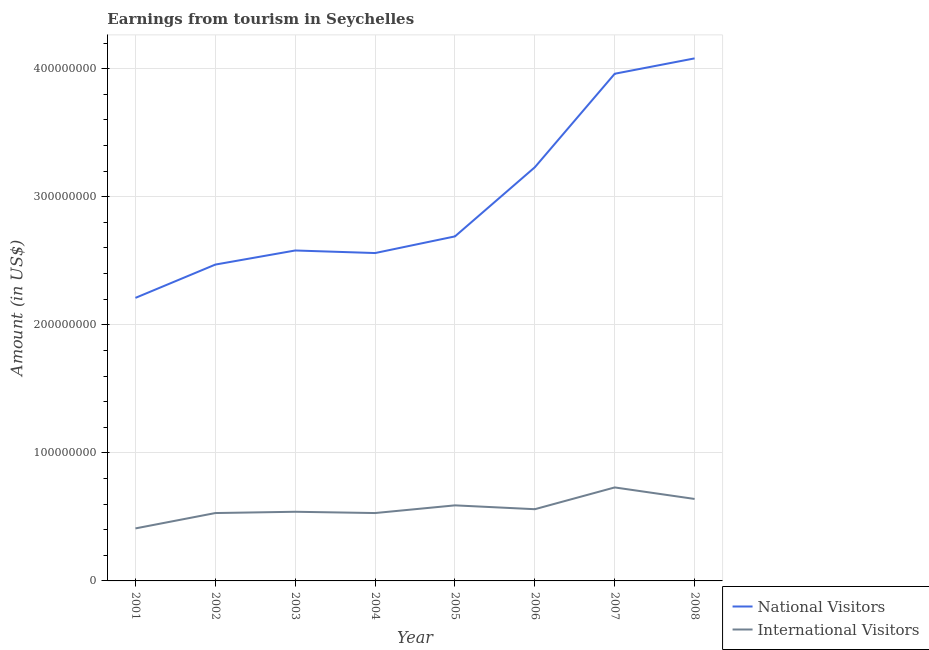Does the line corresponding to amount earned from national visitors intersect with the line corresponding to amount earned from international visitors?
Your answer should be compact. No. What is the amount earned from national visitors in 2007?
Your answer should be very brief. 3.96e+08. Across all years, what is the maximum amount earned from international visitors?
Provide a succinct answer. 7.30e+07. Across all years, what is the minimum amount earned from national visitors?
Your answer should be very brief. 2.21e+08. In which year was the amount earned from international visitors maximum?
Your answer should be compact. 2007. In which year was the amount earned from national visitors minimum?
Offer a very short reply. 2001. What is the total amount earned from international visitors in the graph?
Your response must be concise. 4.53e+08. What is the difference between the amount earned from international visitors in 2001 and that in 2003?
Your answer should be very brief. -1.30e+07. What is the difference between the amount earned from national visitors in 2005 and the amount earned from international visitors in 2001?
Your response must be concise. 2.28e+08. What is the average amount earned from international visitors per year?
Make the answer very short. 5.66e+07. In the year 2008, what is the difference between the amount earned from national visitors and amount earned from international visitors?
Provide a succinct answer. 3.44e+08. What is the ratio of the amount earned from international visitors in 2001 to that in 2003?
Your response must be concise. 0.76. Is the difference between the amount earned from national visitors in 2004 and 2006 greater than the difference between the amount earned from international visitors in 2004 and 2006?
Keep it short and to the point. No. What is the difference between the highest and the lowest amount earned from national visitors?
Your answer should be compact. 1.87e+08. Is the sum of the amount earned from national visitors in 2004 and 2007 greater than the maximum amount earned from international visitors across all years?
Make the answer very short. Yes. Does the amount earned from national visitors monotonically increase over the years?
Keep it short and to the point. No. Is the amount earned from international visitors strictly greater than the amount earned from national visitors over the years?
Provide a succinct answer. No. Is the amount earned from national visitors strictly less than the amount earned from international visitors over the years?
Provide a succinct answer. No. Does the graph contain any zero values?
Give a very brief answer. No. Does the graph contain grids?
Offer a very short reply. Yes. Where does the legend appear in the graph?
Your response must be concise. Bottom right. How are the legend labels stacked?
Offer a terse response. Vertical. What is the title of the graph?
Provide a short and direct response. Earnings from tourism in Seychelles. Does "Food and tobacco" appear as one of the legend labels in the graph?
Offer a terse response. No. What is the Amount (in US$) in National Visitors in 2001?
Offer a terse response. 2.21e+08. What is the Amount (in US$) of International Visitors in 2001?
Make the answer very short. 4.10e+07. What is the Amount (in US$) in National Visitors in 2002?
Make the answer very short. 2.47e+08. What is the Amount (in US$) of International Visitors in 2002?
Give a very brief answer. 5.30e+07. What is the Amount (in US$) in National Visitors in 2003?
Give a very brief answer. 2.58e+08. What is the Amount (in US$) in International Visitors in 2003?
Provide a succinct answer. 5.40e+07. What is the Amount (in US$) in National Visitors in 2004?
Ensure brevity in your answer.  2.56e+08. What is the Amount (in US$) of International Visitors in 2004?
Your answer should be compact. 5.30e+07. What is the Amount (in US$) in National Visitors in 2005?
Your response must be concise. 2.69e+08. What is the Amount (in US$) in International Visitors in 2005?
Provide a short and direct response. 5.90e+07. What is the Amount (in US$) of National Visitors in 2006?
Offer a terse response. 3.23e+08. What is the Amount (in US$) of International Visitors in 2006?
Make the answer very short. 5.60e+07. What is the Amount (in US$) of National Visitors in 2007?
Make the answer very short. 3.96e+08. What is the Amount (in US$) of International Visitors in 2007?
Keep it short and to the point. 7.30e+07. What is the Amount (in US$) in National Visitors in 2008?
Provide a short and direct response. 4.08e+08. What is the Amount (in US$) of International Visitors in 2008?
Give a very brief answer. 6.40e+07. Across all years, what is the maximum Amount (in US$) in National Visitors?
Your answer should be very brief. 4.08e+08. Across all years, what is the maximum Amount (in US$) in International Visitors?
Your answer should be very brief. 7.30e+07. Across all years, what is the minimum Amount (in US$) in National Visitors?
Your answer should be compact. 2.21e+08. Across all years, what is the minimum Amount (in US$) in International Visitors?
Offer a terse response. 4.10e+07. What is the total Amount (in US$) in National Visitors in the graph?
Your response must be concise. 2.38e+09. What is the total Amount (in US$) of International Visitors in the graph?
Your answer should be very brief. 4.53e+08. What is the difference between the Amount (in US$) of National Visitors in 2001 and that in 2002?
Make the answer very short. -2.60e+07. What is the difference between the Amount (in US$) in International Visitors in 2001 and that in 2002?
Give a very brief answer. -1.20e+07. What is the difference between the Amount (in US$) of National Visitors in 2001 and that in 2003?
Your answer should be compact. -3.70e+07. What is the difference between the Amount (in US$) of International Visitors in 2001 and that in 2003?
Your answer should be very brief. -1.30e+07. What is the difference between the Amount (in US$) of National Visitors in 2001 and that in 2004?
Offer a terse response. -3.50e+07. What is the difference between the Amount (in US$) in International Visitors in 2001 and that in 2004?
Make the answer very short. -1.20e+07. What is the difference between the Amount (in US$) in National Visitors in 2001 and that in 2005?
Keep it short and to the point. -4.80e+07. What is the difference between the Amount (in US$) of International Visitors in 2001 and that in 2005?
Make the answer very short. -1.80e+07. What is the difference between the Amount (in US$) of National Visitors in 2001 and that in 2006?
Give a very brief answer. -1.02e+08. What is the difference between the Amount (in US$) in International Visitors in 2001 and that in 2006?
Make the answer very short. -1.50e+07. What is the difference between the Amount (in US$) in National Visitors in 2001 and that in 2007?
Ensure brevity in your answer.  -1.75e+08. What is the difference between the Amount (in US$) in International Visitors in 2001 and that in 2007?
Give a very brief answer. -3.20e+07. What is the difference between the Amount (in US$) in National Visitors in 2001 and that in 2008?
Offer a terse response. -1.87e+08. What is the difference between the Amount (in US$) of International Visitors in 2001 and that in 2008?
Keep it short and to the point. -2.30e+07. What is the difference between the Amount (in US$) of National Visitors in 2002 and that in 2003?
Give a very brief answer. -1.10e+07. What is the difference between the Amount (in US$) in National Visitors in 2002 and that in 2004?
Provide a short and direct response. -9.00e+06. What is the difference between the Amount (in US$) of National Visitors in 2002 and that in 2005?
Ensure brevity in your answer.  -2.20e+07. What is the difference between the Amount (in US$) in International Visitors in 2002 and that in 2005?
Give a very brief answer. -6.00e+06. What is the difference between the Amount (in US$) of National Visitors in 2002 and that in 2006?
Make the answer very short. -7.60e+07. What is the difference between the Amount (in US$) of National Visitors in 2002 and that in 2007?
Give a very brief answer. -1.49e+08. What is the difference between the Amount (in US$) of International Visitors in 2002 and that in 2007?
Make the answer very short. -2.00e+07. What is the difference between the Amount (in US$) of National Visitors in 2002 and that in 2008?
Offer a terse response. -1.61e+08. What is the difference between the Amount (in US$) of International Visitors in 2002 and that in 2008?
Provide a short and direct response. -1.10e+07. What is the difference between the Amount (in US$) in National Visitors in 2003 and that in 2005?
Provide a succinct answer. -1.10e+07. What is the difference between the Amount (in US$) of International Visitors in 2003 and that in 2005?
Offer a very short reply. -5.00e+06. What is the difference between the Amount (in US$) of National Visitors in 2003 and that in 2006?
Your answer should be very brief. -6.50e+07. What is the difference between the Amount (in US$) in International Visitors in 2003 and that in 2006?
Offer a very short reply. -2.00e+06. What is the difference between the Amount (in US$) of National Visitors in 2003 and that in 2007?
Make the answer very short. -1.38e+08. What is the difference between the Amount (in US$) of International Visitors in 2003 and that in 2007?
Make the answer very short. -1.90e+07. What is the difference between the Amount (in US$) of National Visitors in 2003 and that in 2008?
Your answer should be compact. -1.50e+08. What is the difference between the Amount (in US$) of International Visitors in 2003 and that in 2008?
Keep it short and to the point. -1.00e+07. What is the difference between the Amount (in US$) in National Visitors in 2004 and that in 2005?
Ensure brevity in your answer.  -1.30e+07. What is the difference between the Amount (in US$) in International Visitors in 2004 and that in 2005?
Make the answer very short. -6.00e+06. What is the difference between the Amount (in US$) of National Visitors in 2004 and that in 2006?
Provide a short and direct response. -6.70e+07. What is the difference between the Amount (in US$) of International Visitors in 2004 and that in 2006?
Provide a succinct answer. -3.00e+06. What is the difference between the Amount (in US$) of National Visitors in 2004 and that in 2007?
Keep it short and to the point. -1.40e+08. What is the difference between the Amount (in US$) in International Visitors in 2004 and that in 2007?
Offer a terse response. -2.00e+07. What is the difference between the Amount (in US$) of National Visitors in 2004 and that in 2008?
Give a very brief answer. -1.52e+08. What is the difference between the Amount (in US$) in International Visitors in 2004 and that in 2008?
Your answer should be compact. -1.10e+07. What is the difference between the Amount (in US$) of National Visitors in 2005 and that in 2006?
Offer a very short reply. -5.40e+07. What is the difference between the Amount (in US$) in International Visitors in 2005 and that in 2006?
Your answer should be compact. 3.00e+06. What is the difference between the Amount (in US$) in National Visitors in 2005 and that in 2007?
Ensure brevity in your answer.  -1.27e+08. What is the difference between the Amount (in US$) of International Visitors in 2005 and that in 2007?
Ensure brevity in your answer.  -1.40e+07. What is the difference between the Amount (in US$) of National Visitors in 2005 and that in 2008?
Offer a terse response. -1.39e+08. What is the difference between the Amount (in US$) in International Visitors in 2005 and that in 2008?
Make the answer very short. -5.00e+06. What is the difference between the Amount (in US$) of National Visitors in 2006 and that in 2007?
Your answer should be very brief. -7.30e+07. What is the difference between the Amount (in US$) of International Visitors in 2006 and that in 2007?
Your answer should be very brief. -1.70e+07. What is the difference between the Amount (in US$) in National Visitors in 2006 and that in 2008?
Keep it short and to the point. -8.50e+07. What is the difference between the Amount (in US$) of International Visitors in 2006 and that in 2008?
Ensure brevity in your answer.  -8.00e+06. What is the difference between the Amount (in US$) in National Visitors in 2007 and that in 2008?
Offer a terse response. -1.20e+07. What is the difference between the Amount (in US$) of International Visitors in 2007 and that in 2008?
Your answer should be compact. 9.00e+06. What is the difference between the Amount (in US$) in National Visitors in 2001 and the Amount (in US$) in International Visitors in 2002?
Offer a terse response. 1.68e+08. What is the difference between the Amount (in US$) of National Visitors in 2001 and the Amount (in US$) of International Visitors in 2003?
Give a very brief answer. 1.67e+08. What is the difference between the Amount (in US$) of National Visitors in 2001 and the Amount (in US$) of International Visitors in 2004?
Keep it short and to the point. 1.68e+08. What is the difference between the Amount (in US$) in National Visitors in 2001 and the Amount (in US$) in International Visitors in 2005?
Your response must be concise. 1.62e+08. What is the difference between the Amount (in US$) of National Visitors in 2001 and the Amount (in US$) of International Visitors in 2006?
Give a very brief answer. 1.65e+08. What is the difference between the Amount (in US$) in National Visitors in 2001 and the Amount (in US$) in International Visitors in 2007?
Make the answer very short. 1.48e+08. What is the difference between the Amount (in US$) in National Visitors in 2001 and the Amount (in US$) in International Visitors in 2008?
Your answer should be compact. 1.57e+08. What is the difference between the Amount (in US$) of National Visitors in 2002 and the Amount (in US$) of International Visitors in 2003?
Make the answer very short. 1.93e+08. What is the difference between the Amount (in US$) of National Visitors in 2002 and the Amount (in US$) of International Visitors in 2004?
Offer a terse response. 1.94e+08. What is the difference between the Amount (in US$) in National Visitors in 2002 and the Amount (in US$) in International Visitors in 2005?
Ensure brevity in your answer.  1.88e+08. What is the difference between the Amount (in US$) of National Visitors in 2002 and the Amount (in US$) of International Visitors in 2006?
Make the answer very short. 1.91e+08. What is the difference between the Amount (in US$) of National Visitors in 2002 and the Amount (in US$) of International Visitors in 2007?
Make the answer very short. 1.74e+08. What is the difference between the Amount (in US$) in National Visitors in 2002 and the Amount (in US$) in International Visitors in 2008?
Provide a short and direct response. 1.83e+08. What is the difference between the Amount (in US$) of National Visitors in 2003 and the Amount (in US$) of International Visitors in 2004?
Provide a succinct answer. 2.05e+08. What is the difference between the Amount (in US$) of National Visitors in 2003 and the Amount (in US$) of International Visitors in 2005?
Your response must be concise. 1.99e+08. What is the difference between the Amount (in US$) in National Visitors in 2003 and the Amount (in US$) in International Visitors in 2006?
Offer a terse response. 2.02e+08. What is the difference between the Amount (in US$) in National Visitors in 2003 and the Amount (in US$) in International Visitors in 2007?
Your answer should be compact. 1.85e+08. What is the difference between the Amount (in US$) of National Visitors in 2003 and the Amount (in US$) of International Visitors in 2008?
Keep it short and to the point. 1.94e+08. What is the difference between the Amount (in US$) in National Visitors in 2004 and the Amount (in US$) in International Visitors in 2005?
Your answer should be compact. 1.97e+08. What is the difference between the Amount (in US$) in National Visitors in 2004 and the Amount (in US$) in International Visitors in 2006?
Give a very brief answer. 2.00e+08. What is the difference between the Amount (in US$) of National Visitors in 2004 and the Amount (in US$) of International Visitors in 2007?
Provide a short and direct response. 1.83e+08. What is the difference between the Amount (in US$) in National Visitors in 2004 and the Amount (in US$) in International Visitors in 2008?
Offer a very short reply. 1.92e+08. What is the difference between the Amount (in US$) in National Visitors in 2005 and the Amount (in US$) in International Visitors in 2006?
Your response must be concise. 2.13e+08. What is the difference between the Amount (in US$) of National Visitors in 2005 and the Amount (in US$) of International Visitors in 2007?
Provide a short and direct response. 1.96e+08. What is the difference between the Amount (in US$) of National Visitors in 2005 and the Amount (in US$) of International Visitors in 2008?
Provide a succinct answer. 2.05e+08. What is the difference between the Amount (in US$) of National Visitors in 2006 and the Amount (in US$) of International Visitors in 2007?
Make the answer very short. 2.50e+08. What is the difference between the Amount (in US$) in National Visitors in 2006 and the Amount (in US$) in International Visitors in 2008?
Offer a very short reply. 2.59e+08. What is the difference between the Amount (in US$) of National Visitors in 2007 and the Amount (in US$) of International Visitors in 2008?
Make the answer very short. 3.32e+08. What is the average Amount (in US$) of National Visitors per year?
Give a very brief answer. 2.97e+08. What is the average Amount (in US$) in International Visitors per year?
Offer a terse response. 5.66e+07. In the year 2001, what is the difference between the Amount (in US$) of National Visitors and Amount (in US$) of International Visitors?
Provide a succinct answer. 1.80e+08. In the year 2002, what is the difference between the Amount (in US$) of National Visitors and Amount (in US$) of International Visitors?
Give a very brief answer. 1.94e+08. In the year 2003, what is the difference between the Amount (in US$) of National Visitors and Amount (in US$) of International Visitors?
Ensure brevity in your answer.  2.04e+08. In the year 2004, what is the difference between the Amount (in US$) in National Visitors and Amount (in US$) in International Visitors?
Give a very brief answer. 2.03e+08. In the year 2005, what is the difference between the Amount (in US$) in National Visitors and Amount (in US$) in International Visitors?
Ensure brevity in your answer.  2.10e+08. In the year 2006, what is the difference between the Amount (in US$) in National Visitors and Amount (in US$) in International Visitors?
Your answer should be compact. 2.67e+08. In the year 2007, what is the difference between the Amount (in US$) in National Visitors and Amount (in US$) in International Visitors?
Ensure brevity in your answer.  3.23e+08. In the year 2008, what is the difference between the Amount (in US$) in National Visitors and Amount (in US$) in International Visitors?
Offer a very short reply. 3.44e+08. What is the ratio of the Amount (in US$) in National Visitors in 2001 to that in 2002?
Provide a succinct answer. 0.89. What is the ratio of the Amount (in US$) of International Visitors in 2001 to that in 2002?
Provide a succinct answer. 0.77. What is the ratio of the Amount (in US$) of National Visitors in 2001 to that in 2003?
Offer a terse response. 0.86. What is the ratio of the Amount (in US$) of International Visitors in 2001 to that in 2003?
Offer a terse response. 0.76. What is the ratio of the Amount (in US$) in National Visitors in 2001 to that in 2004?
Keep it short and to the point. 0.86. What is the ratio of the Amount (in US$) of International Visitors in 2001 to that in 2004?
Offer a very short reply. 0.77. What is the ratio of the Amount (in US$) of National Visitors in 2001 to that in 2005?
Ensure brevity in your answer.  0.82. What is the ratio of the Amount (in US$) of International Visitors in 2001 to that in 2005?
Provide a short and direct response. 0.69. What is the ratio of the Amount (in US$) in National Visitors in 2001 to that in 2006?
Your answer should be compact. 0.68. What is the ratio of the Amount (in US$) in International Visitors in 2001 to that in 2006?
Your answer should be compact. 0.73. What is the ratio of the Amount (in US$) of National Visitors in 2001 to that in 2007?
Keep it short and to the point. 0.56. What is the ratio of the Amount (in US$) of International Visitors in 2001 to that in 2007?
Offer a terse response. 0.56. What is the ratio of the Amount (in US$) of National Visitors in 2001 to that in 2008?
Your answer should be compact. 0.54. What is the ratio of the Amount (in US$) in International Visitors in 2001 to that in 2008?
Provide a short and direct response. 0.64. What is the ratio of the Amount (in US$) of National Visitors in 2002 to that in 2003?
Provide a short and direct response. 0.96. What is the ratio of the Amount (in US$) in International Visitors in 2002 to that in 2003?
Ensure brevity in your answer.  0.98. What is the ratio of the Amount (in US$) in National Visitors in 2002 to that in 2004?
Keep it short and to the point. 0.96. What is the ratio of the Amount (in US$) of National Visitors in 2002 to that in 2005?
Your response must be concise. 0.92. What is the ratio of the Amount (in US$) in International Visitors in 2002 to that in 2005?
Make the answer very short. 0.9. What is the ratio of the Amount (in US$) of National Visitors in 2002 to that in 2006?
Make the answer very short. 0.76. What is the ratio of the Amount (in US$) of International Visitors in 2002 to that in 2006?
Keep it short and to the point. 0.95. What is the ratio of the Amount (in US$) of National Visitors in 2002 to that in 2007?
Your answer should be compact. 0.62. What is the ratio of the Amount (in US$) in International Visitors in 2002 to that in 2007?
Provide a short and direct response. 0.73. What is the ratio of the Amount (in US$) in National Visitors in 2002 to that in 2008?
Keep it short and to the point. 0.61. What is the ratio of the Amount (in US$) of International Visitors in 2002 to that in 2008?
Provide a succinct answer. 0.83. What is the ratio of the Amount (in US$) of National Visitors in 2003 to that in 2004?
Your answer should be compact. 1.01. What is the ratio of the Amount (in US$) in International Visitors in 2003 to that in 2004?
Provide a short and direct response. 1.02. What is the ratio of the Amount (in US$) of National Visitors in 2003 to that in 2005?
Offer a terse response. 0.96. What is the ratio of the Amount (in US$) of International Visitors in 2003 to that in 2005?
Give a very brief answer. 0.92. What is the ratio of the Amount (in US$) of National Visitors in 2003 to that in 2006?
Your response must be concise. 0.8. What is the ratio of the Amount (in US$) in National Visitors in 2003 to that in 2007?
Ensure brevity in your answer.  0.65. What is the ratio of the Amount (in US$) of International Visitors in 2003 to that in 2007?
Your answer should be compact. 0.74. What is the ratio of the Amount (in US$) in National Visitors in 2003 to that in 2008?
Your response must be concise. 0.63. What is the ratio of the Amount (in US$) in International Visitors in 2003 to that in 2008?
Provide a succinct answer. 0.84. What is the ratio of the Amount (in US$) in National Visitors in 2004 to that in 2005?
Offer a very short reply. 0.95. What is the ratio of the Amount (in US$) in International Visitors in 2004 to that in 2005?
Provide a short and direct response. 0.9. What is the ratio of the Amount (in US$) of National Visitors in 2004 to that in 2006?
Your answer should be very brief. 0.79. What is the ratio of the Amount (in US$) in International Visitors in 2004 to that in 2006?
Keep it short and to the point. 0.95. What is the ratio of the Amount (in US$) in National Visitors in 2004 to that in 2007?
Make the answer very short. 0.65. What is the ratio of the Amount (in US$) in International Visitors in 2004 to that in 2007?
Offer a terse response. 0.73. What is the ratio of the Amount (in US$) of National Visitors in 2004 to that in 2008?
Make the answer very short. 0.63. What is the ratio of the Amount (in US$) in International Visitors in 2004 to that in 2008?
Give a very brief answer. 0.83. What is the ratio of the Amount (in US$) in National Visitors in 2005 to that in 2006?
Offer a terse response. 0.83. What is the ratio of the Amount (in US$) of International Visitors in 2005 to that in 2006?
Your answer should be compact. 1.05. What is the ratio of the Amount (in US$) of National Visitors in 2005 to that in 2007?
Your answer should be compact. 0.68. What is the ratio of the Amount (in US$) of International Visitors in 2005 to that in 2007?
Give a very brief answer. 0.81. What is the ratio of the Amount (in US$) of National Visitors in 2005 to that in 2008?
Your answer should be compact. 0.66. What is the ratio of the Amount (in US$) of International Visitors in 2005 to that in 2008?
Offer a terse response. 0.92. What is the ratio of the Amount (in US$) of National Visitors in 2006 to that in 2007?
Keep it short and to the point. 0.82. What is the ratio of the Amount (in US$) of International Visitors in 2006 to that in 2007?
Your response must be concise. 0.77. What is the ratio of the Amount (in US$) of National Visitors in 2006 to that in 2008?
Keep it short and to the point. 0.79. What is the ratio of the Amount (in US$) of National Visitors in 2007 to that in 2008?
Offer a terse response. 0.97. What is the ratio of the Amount (in US$) of International Visitors in 2007 to that in 2008?
Offer a terse response. 1.14. What is the difference between the highest and the second highest Amount (in US$) of National Visitors?
Provide a short and direct response. 1.20e+07. What is the difference between the highest and the second highest Amount (in US$) in International Visitors?
Provide a succinct answer. 9.00e+06. What is the difference between the highest and the lowest Amount (in US$) of National Visitors?
Make the answer very short. 1.87e+08. What is the difference between the highest and the lowest Amount (in US$) of International Visitors?
Ensure brevity in your answer.  3.20e+07. 